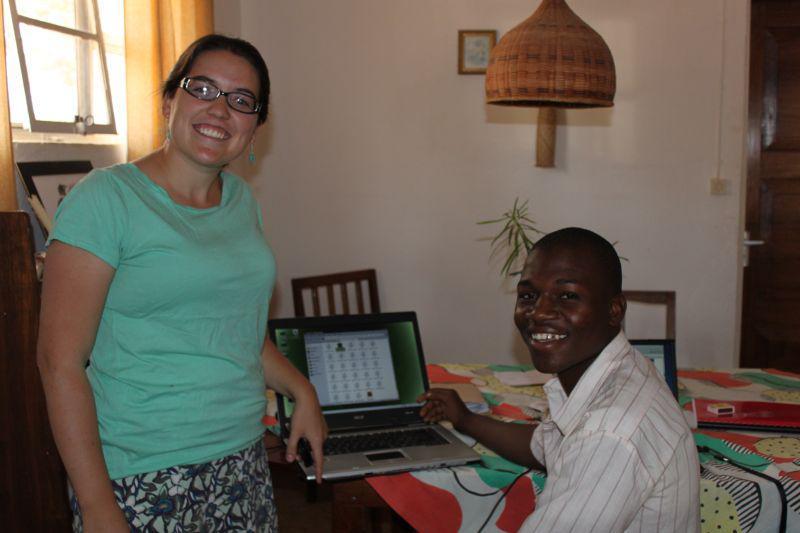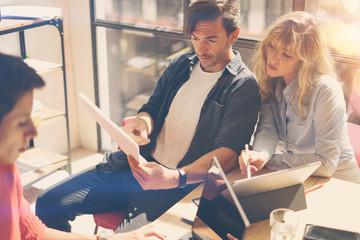The first image is the image on the left, the second image is the image on the right. Analyze the images presented: Is the assertion "The left image shows a person leaning in to look at an open laptop in front of a different person, and the right image includes a man in a necktie sitting behind a laptop." valid? Answer yes or no. No. The first image is the image on the left, the second image is the image on the right. For the images displayed, is the sentence "The right image contains a man wearing a white shirt with a black tie." factually correct? Answer yes or no. No. 